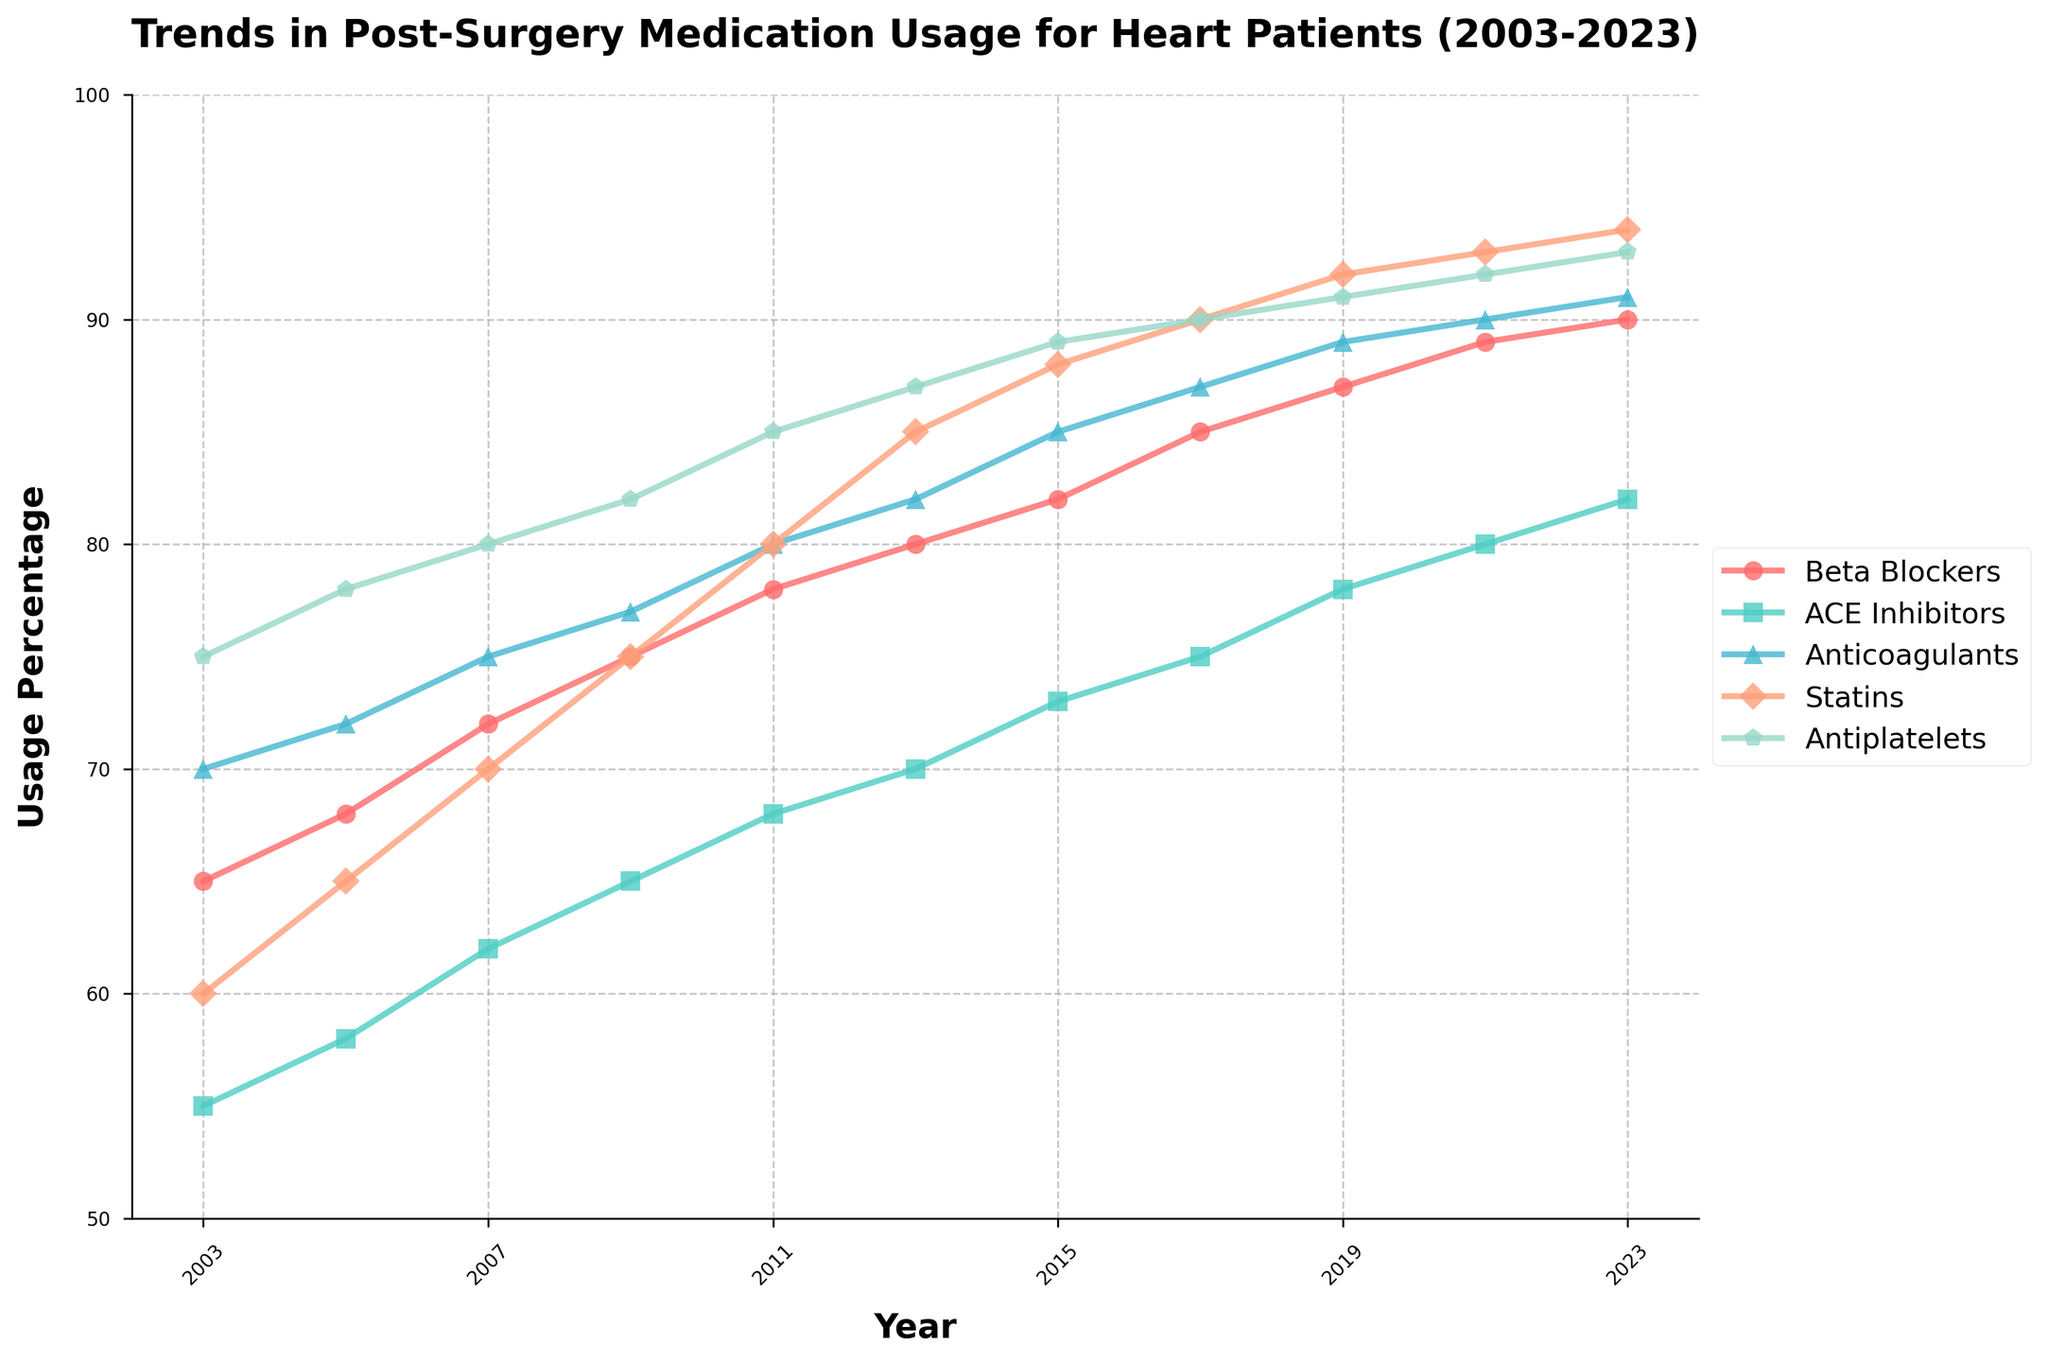What medication had the highest usage percentage in 2023? By looking at the figure and identifying which line reaches the highest value in 2023, it is clear the line for Antiplatelets reaches a usage of 93%.
Answer: Antiplatelets How did the usage percentage of Beta Blockers change from 2003 to 2023? The figure shows that the percentage of Beta Blockers started at 65% in 2003 and increased to 90% in 2023, resulting in a change of 25%.
Answer: Increased by 25% Which medication had the smallest change in usage percentage from 2003 to 2023? By comparing the differences for each medication over the period: Beta Blockers (25%), ACE Inhibitors (27%), Anticoagulants (21%), Statins (34%), Antiplatelets (18%), it is clear that Antiplatelets had the smallest change.
Answer: Antiplatelets In what year did Statins surpass an 80% usage percentage? The plot of Statins crosses the 80% line between 2011 and 2013. Checking the exact values shows that Statins had 85% usage in 2013.
Answer: 2013 Which medication increased at a faster rate between 2005 and 2015: ACE Inhibitors or Statins? ACE Inhibitors increased from 58% to 73% (a 15% increase), while Statins increased from 65% to 88% (a 23% increase) between the same years. Therefore, Statins had a faster increase.
Answer: Statins What is the average usage percentage of Anticoagulants from 2003 to 2023? Sum the usage percentages for Anticoagulants over the years given: 70 + 72 + 75 + 77 + 80 + 82 + 85 + 87 + 89 + 90 + 91 = 898. Then, divide by the number of data points: 898 / 11.
Answer: 81.6 Which two medications have the most similar usage percentage trends over the 20-year period? By inspecting the lines, ACE Inhibitors and Antiplatelets appear to have the most similar trends, both maintaining a steady increase over the period.
Answer: ACE Inhibitors and Antiplatelets Between which two years did Beta Blockers see the greatest increase in usage percentage? The largest increase for Beta Blockers occurred between 2011 and 2013, where it went from 78% to 80%, a 2% increase. This pattern is consistent compared to other years.
Answer: 2011 to 2013 How many years did it take for Antiplatelets to reach a 90% usage percentage after 2003? Looking at the data points, Antiplatelets reached 90% usage in 2017, starting from 75% in 2003. This took 14 years.
Answer: 14 years 